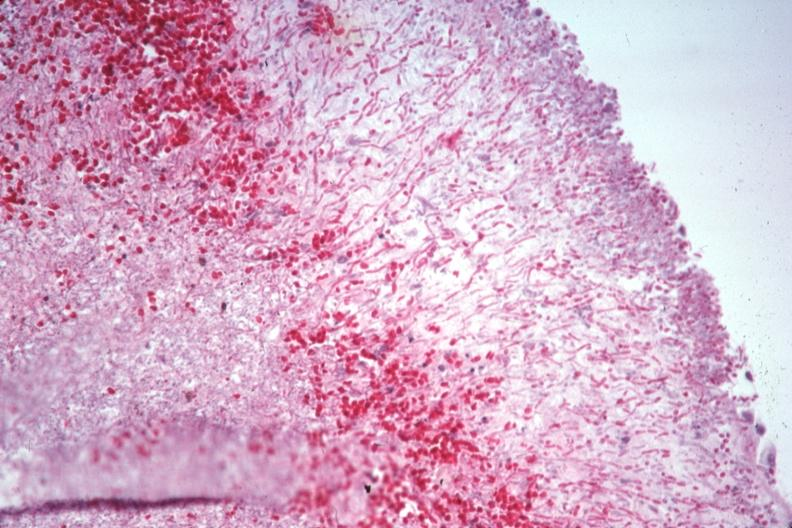does cm show pas large number pseudohyphae penetrating capsule which can not be recognized as spleen?
Answer the question using a single word or phrase. No 